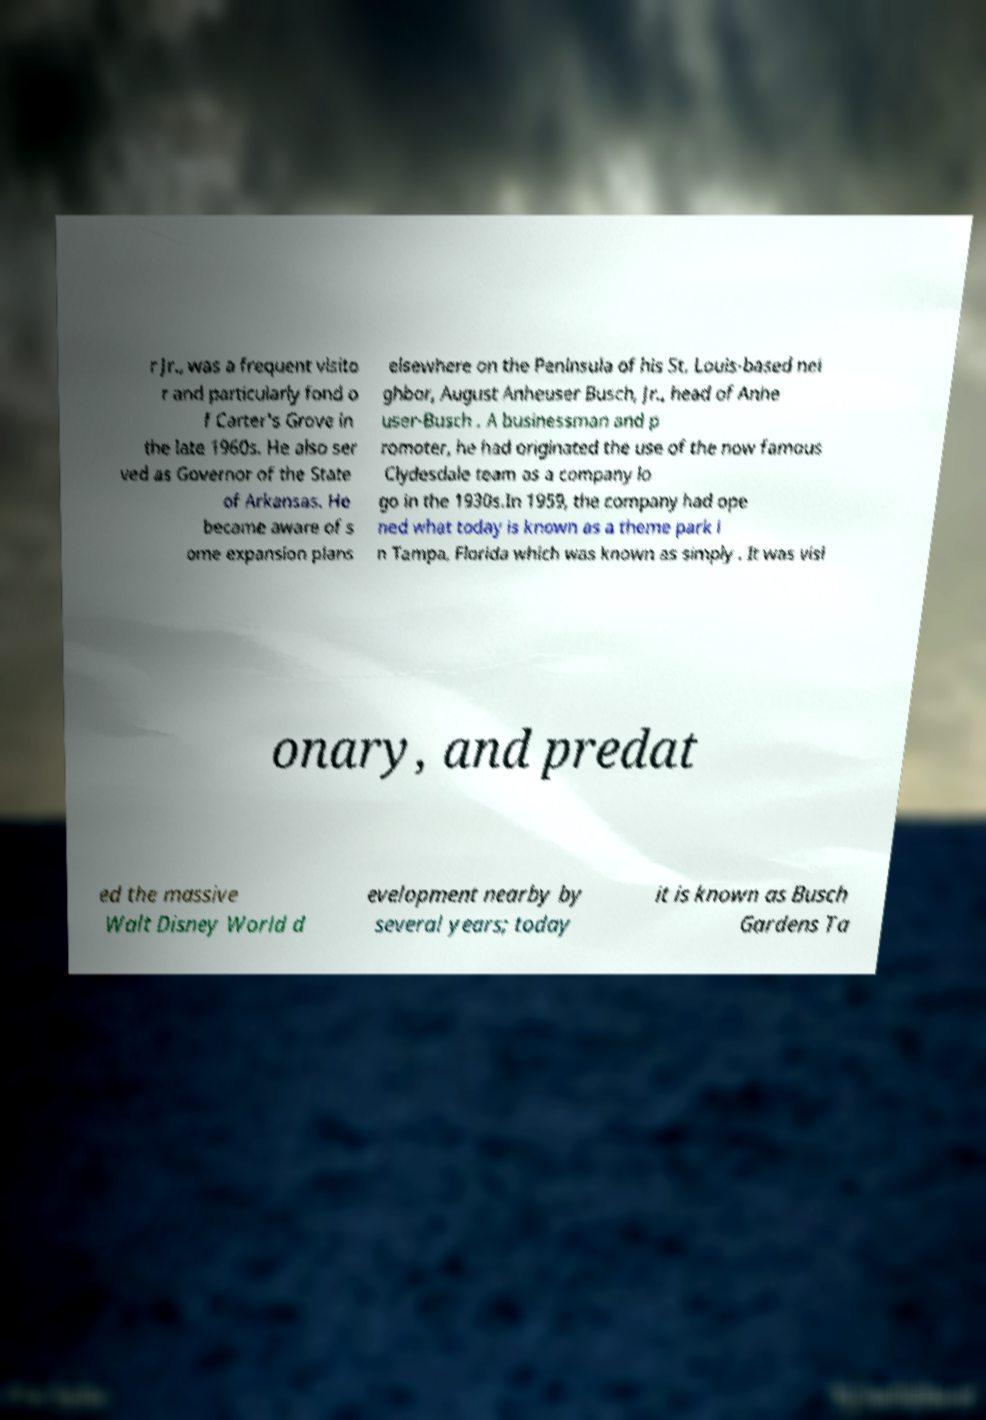Please read and relay the text visible in this image. What does it say? r Jr., was a frequent visito r and particularly fond o f Carter's Grove in the late 1960s. He also ser ved as Governor of the State of Arkansas. He became aware of s ome expansion plans elsewhere on the Peninsula of his St. Louis-based nei ghbor, August Anheuser Busch, Jr., head of Anhe user-Busch . A businessman and p romoter, he had originated the use of the now famous Clydesdale team as a company lo go in the 1930s.In 1959, the company had ope ned what today is known as a theme park i n Tampa, Florida which was known as simply . It was visi onary, and predat ed the massive Walt Disney World d evelopment nearby by several years; today it is known as Busch Gardens Ta 